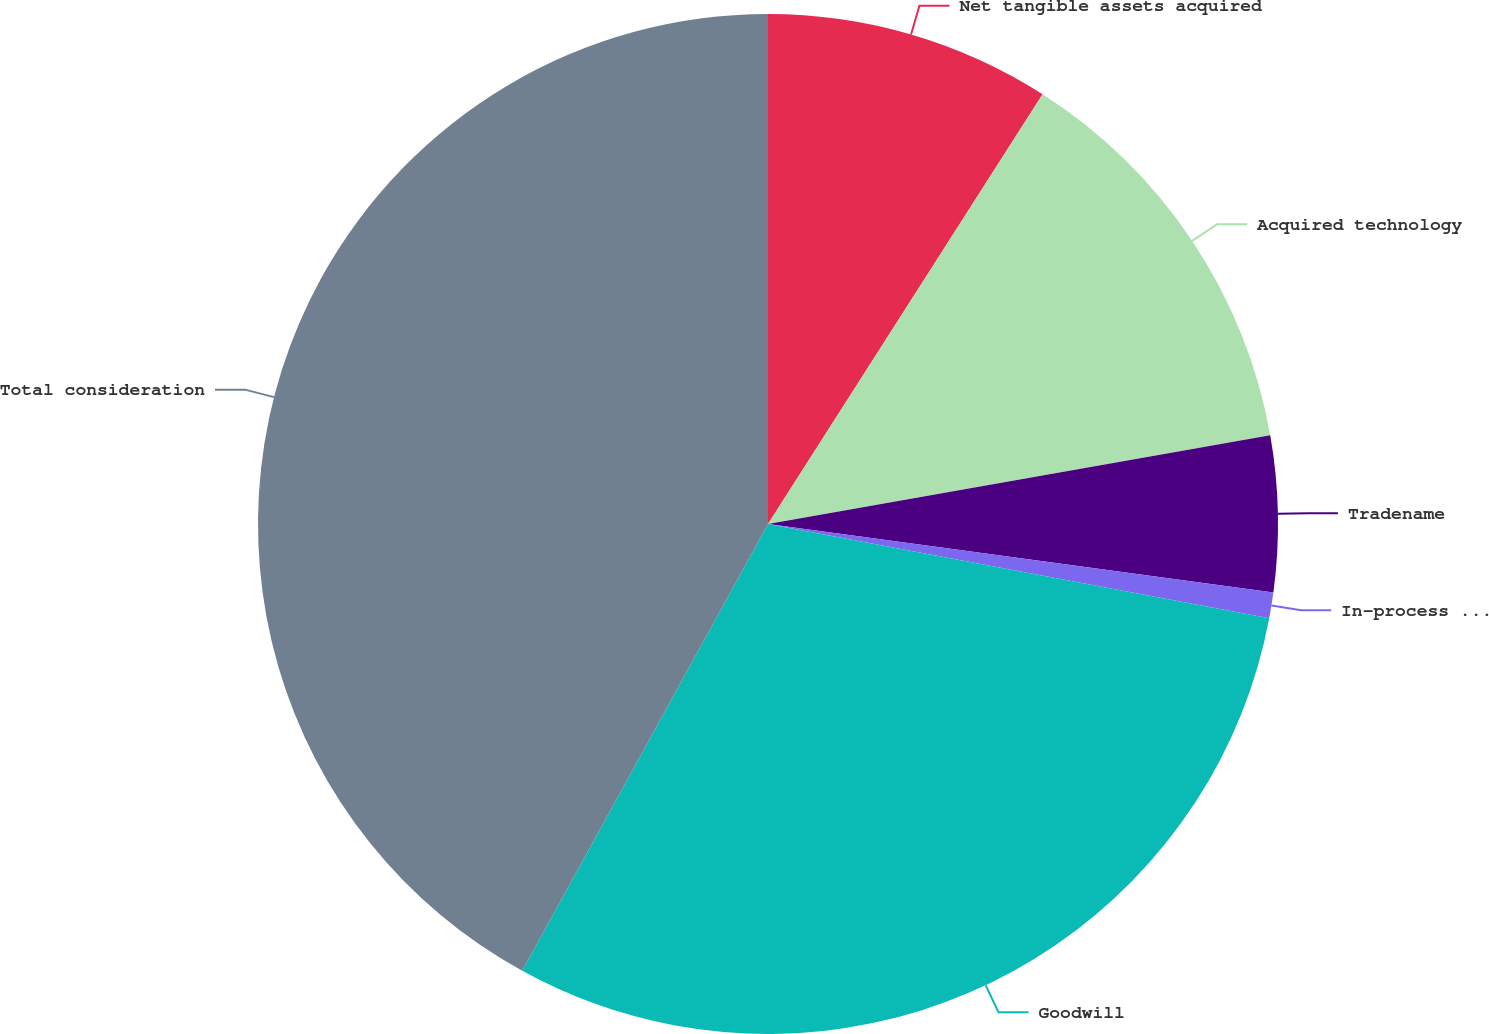<chart> <loc_0><loc_0><loc_500><loc_500><pie_chart><fcel>Net tangible assets acquired<fcel>Acquired technology<fcel>Tradename<fcel>In-process research and<fcel>Goodwill<fcel>Total consideration<nl><fcel>9.05%<fcel>13.17%<fcel>4.93%<fcel>0.81%<fcel>30.05%<fcel>42.0%<nl></chart> 